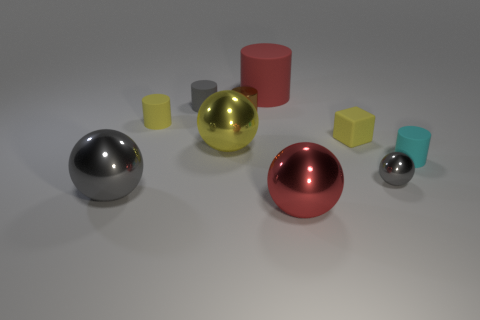Subtract all gray matte cylinders. How many cylinders are left? 4 Subtract all yellow cylinders. How many cylinders are left? 4 Subtract all purple cylinders. Subtract all green spheres. How many cylinders are left? 5 Subtract all balls. How many objects are left? 6 Add 6 matte spheres. How many matte spheres exist? 6 Subtract 0 green cylinders. How many objects are left? 10 Subtract all yellow cylinders. Subtract all tiny gray metal balls. How many objects are left? 8 Add 6 small brown metallic things. How many small brown metallic things are left? 7 